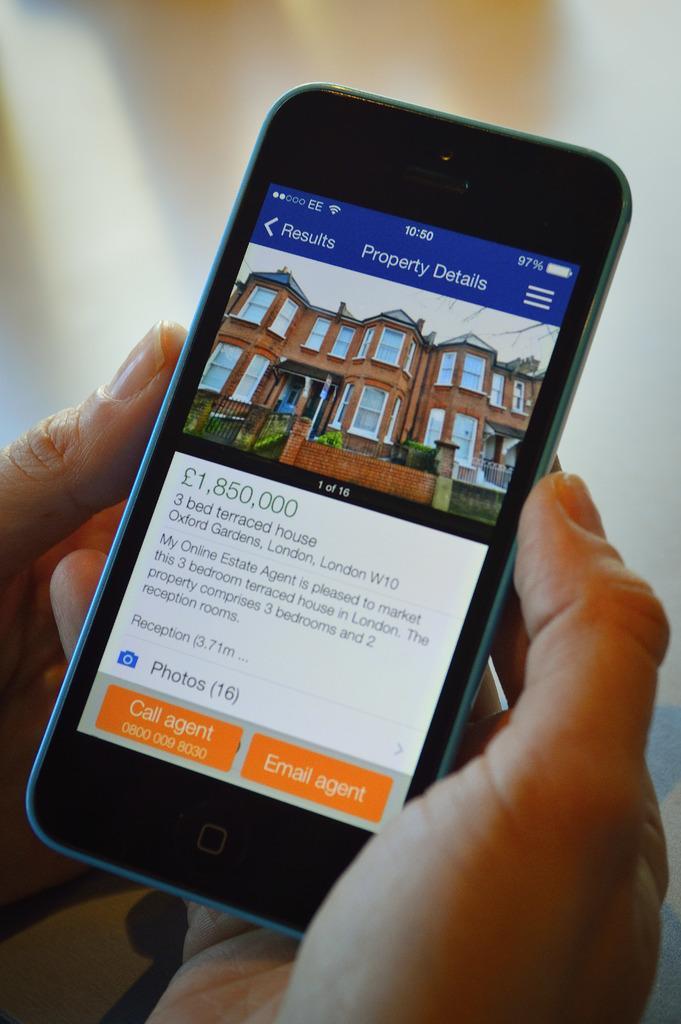Could you give a brief overview of what you see in this image? In this picture we can see a mobile in a person's hands and in the background it is blurry. 